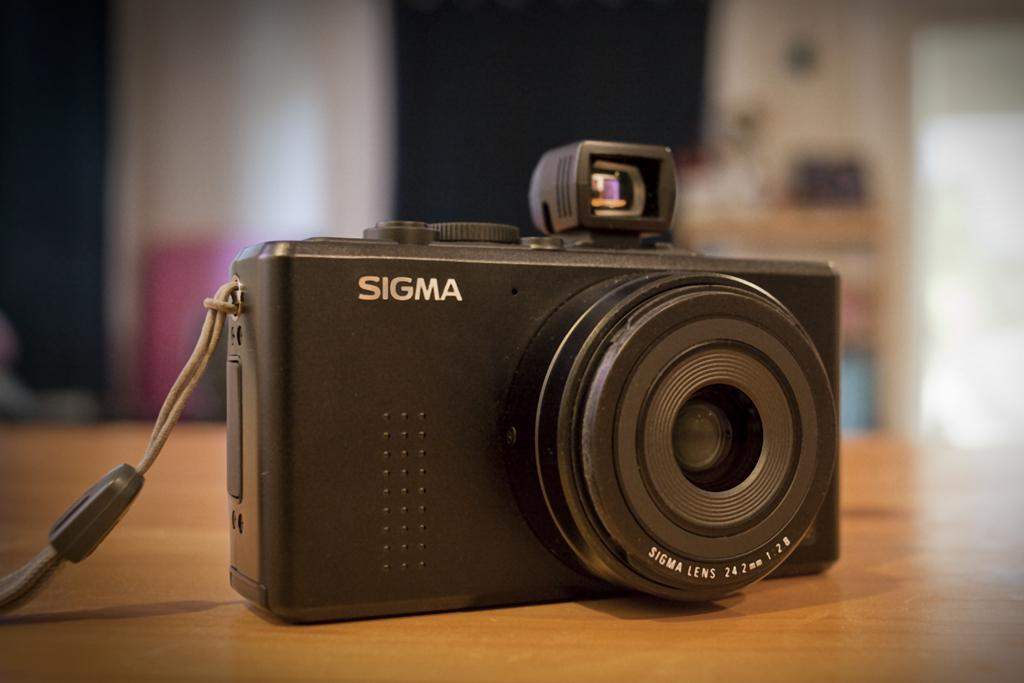What object is the main subject of the image? There is a camera in the image. Where is the camera placed? The camera is on a wooden table. What additional detail can be seen on the camera? There is text on the camera. Can you describe the background of the image? The background of the image is blurry. How does the camera help people trip over power cords in the image? There are no people, trip, or power cords mentioned in the image; it only features a camera on a wooden table with a blurry background. 